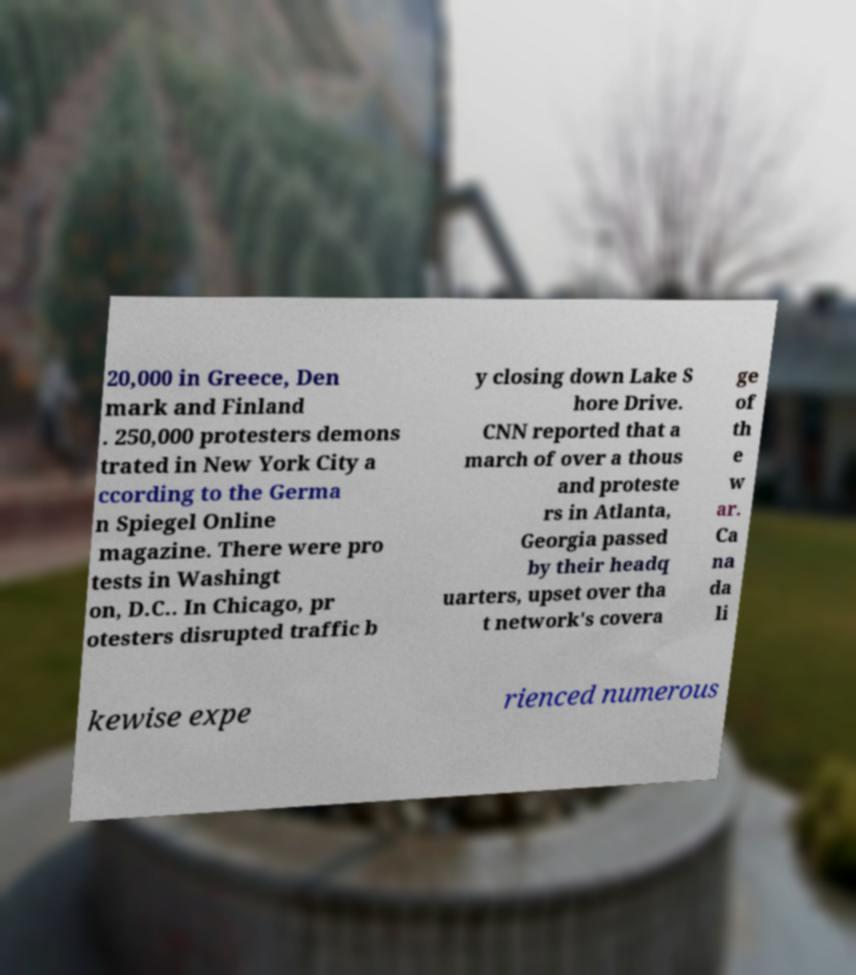Can you accurately transcribe the text from the provided image for me? 20,000 in Greece, Den mark and Finland . 250,000 protesters demons trated in New York City a ccording to the Germa n Spiegel Online magazine. There were pro tests in Washingt on, D.C.. In Chicago, pr otesters disrupted traffic b y closing down Lake S hore Drive. CNN reported that a march of over a thous and proteste rs in Atlanta, Georgia passed by their headq uarters, upset over tha t network's covera ge of th e w ar. Ca na da li kewise expe rienced numerous 